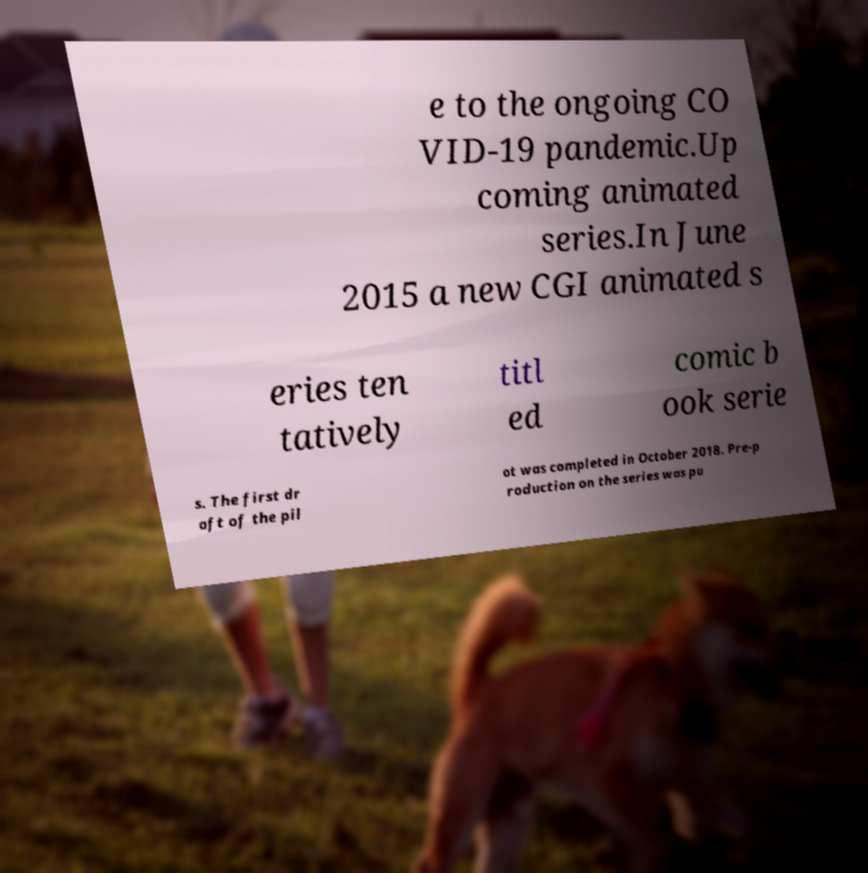Please identify and transcribe the text found in this image. e to the ongoing CO VID-19 pandemic.Up coming animated series.In June 2015 a new CGI animated s eries ten tatively titl ed comic b ook serie s. The first dr aft of the pil ot was completed in October 2018. Pre-p roduction on the series was pu 